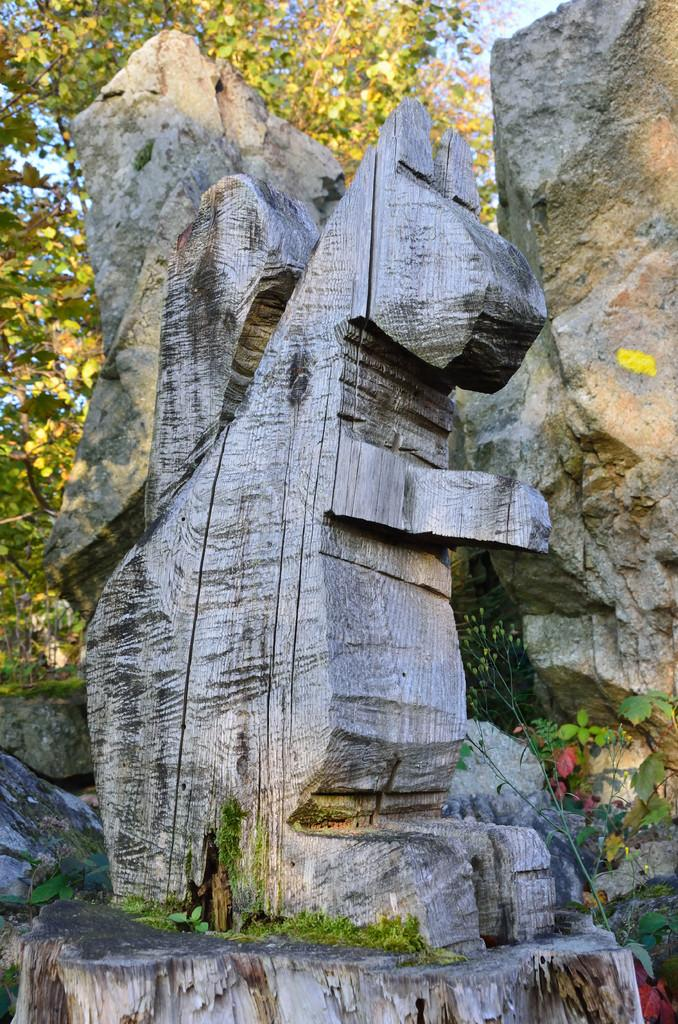What is the main subject of the image? There is a wooden statue in the image. How is the wooden statue created? The statue is carved on a tree. What can be seen in the background of the image? There are stones in the background of the image. What type of vegetation is visible behind the stones? Trees are present behind the stones in the background. What type of attraction is the statue a part of in the image? There is no indication in the image that the statue is a part of any attraction. How does the statue twist in the image? The statue does not twist in the image; it is a stationary wooden carving on a tree. 